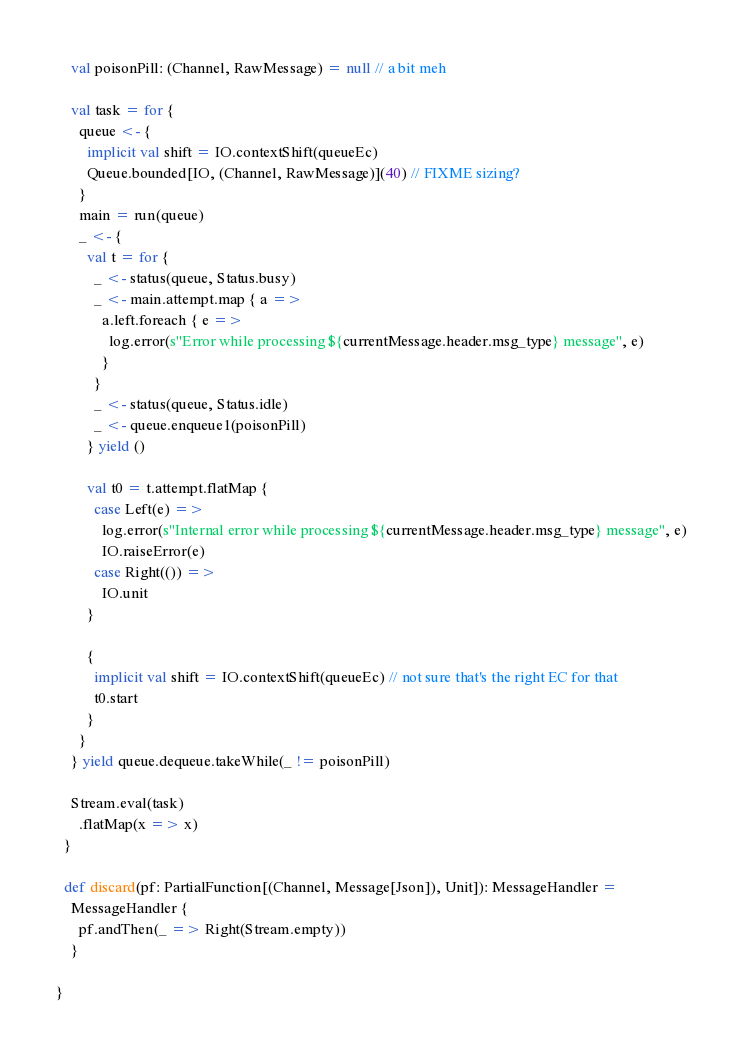Convert code to text. <code><loc_0><loc_0><loc_500><loc_500><_Scala_>
    val poisonPill: (Channel, RawMessage) = null // a bit meh

    val task = for {
      queue <- {
        implicit val shift = IO.contextShift(queueEc)
        Queue.bounded[IO, (Channel, RawMessage)](40) // FIXME sizing?
      }
      main = run(queue)
      _ <- {
        val t = for {
          _ <- status(queue, Status.busy)
          _ <- main.attempt.map { a =>
            a.left.foreach { e =>
              log.error(s"Error while processing ${currentMessage.header.msg_type} message", e)
            }
          }
          _ <- status(queue, Status.idle)
          _ <- queue.enqueue1(poisonPill)
        } yield ()

        val t0 = t.attempt.flatMap {
          case Left(e) =>
            log.error(s"Internal error while processing ${currentMessage.header.msg_type} message", e)
            IO.raiseError(e)
          case Right(()) =>
            IO.unit
        }

        {
          implicit val shift = IO.contextShift(queueEc) // not sure that's the right EC for that
          t0.start
        }
      }
    } yield queue.dequeue.takeWhile(_ != poisonPill)

    Stream.eval(task)
      .flatMap(x => x)
  }

  def discard(pf: PartialFunction[(Channel, Message[Json]), Unit]): MessageHandler =
    MessageHandler {
      pf.andThen(_ => Right(Stream.empty))
    }

}
</code> 